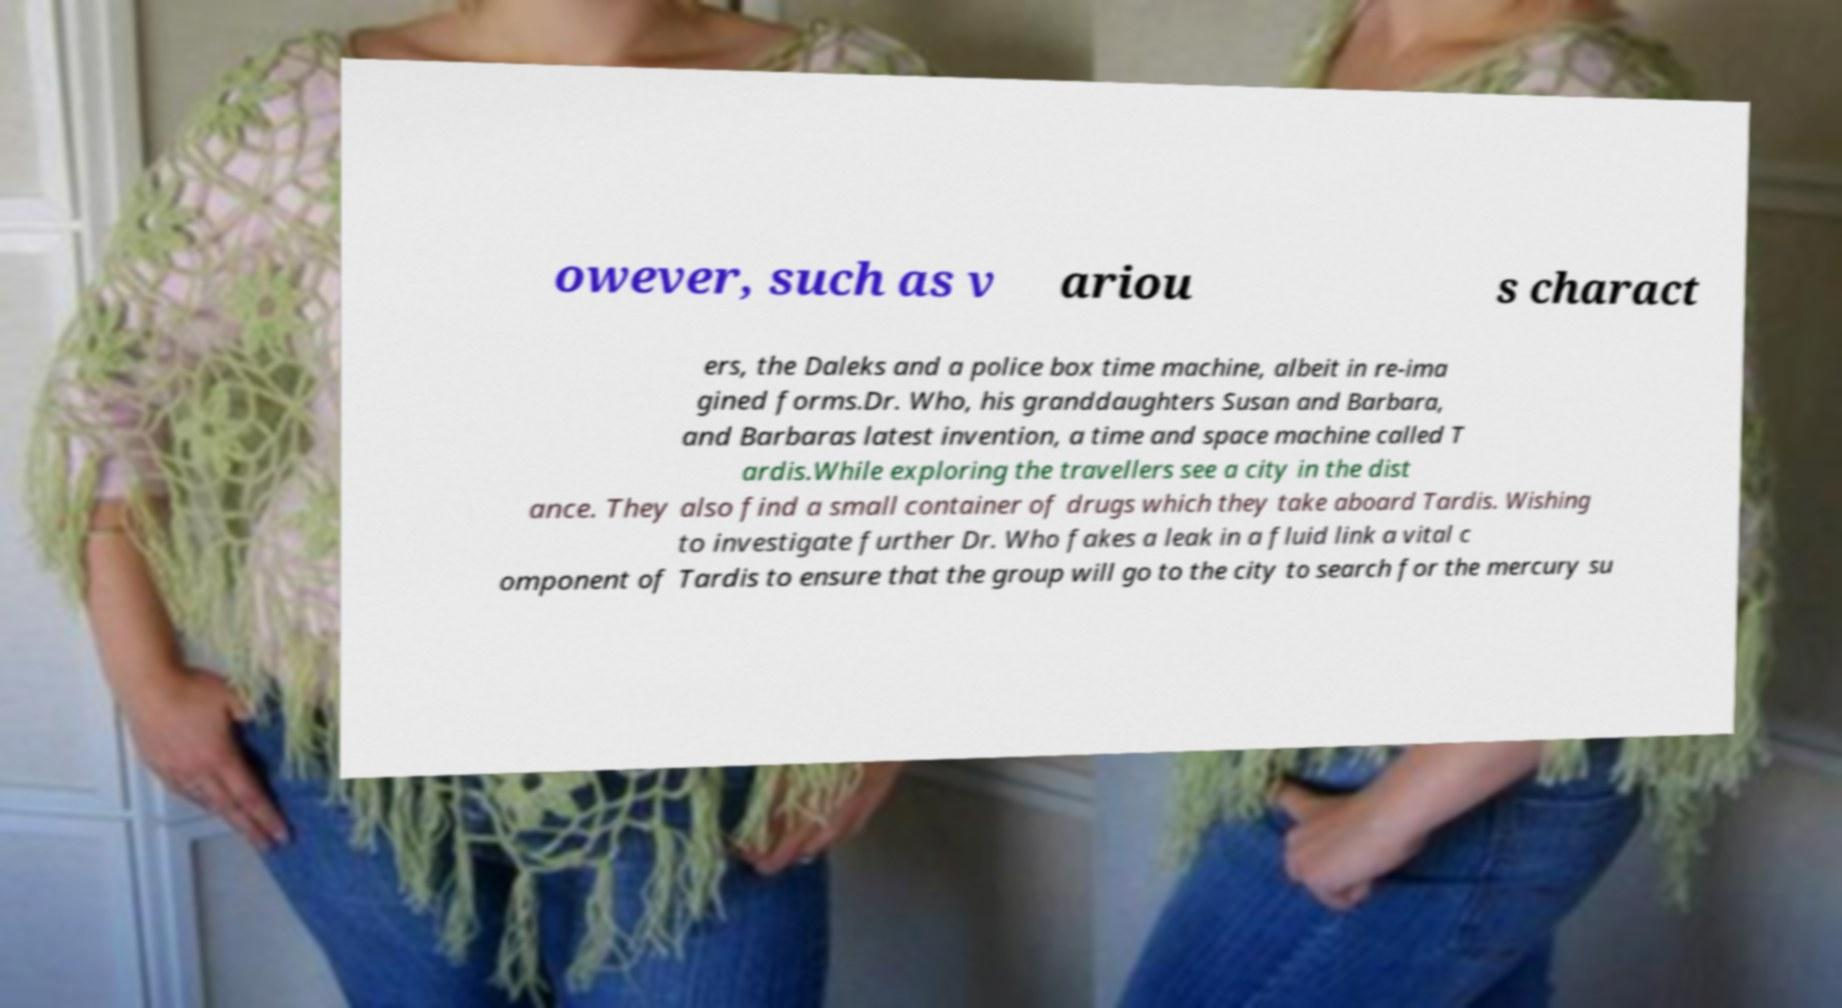Please identify and transcribe the text found in this image. owever, such as v ariou s charact ers, the Daleks and a police box time machine, albeit in re-ima gined forms.Dr. Who, his granddaughters Susan and Barbara, and Barbaras latest invention, a time and space machine called T ardis.While exploring the travellers see a city in the dist ance. They also find a small container of drugs which they take aboard Tardis. Wishing to investigate further Dr. Who fakes a leak in a fluid link a vital c omponent of Tardis to ensure that the group will go to the city to search for the mercury su 